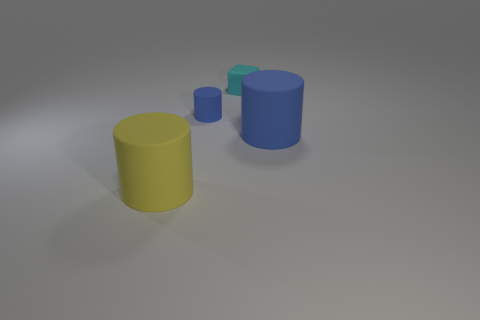How many blue cylinders must be subtracted to get 1 blue cylinders? 1 Subtract all brown spheres. How many blue cylinders are left? 2 Subtract all large cylinders. How many cylinders are left? 1 Subtract all gray cylinders. Subtract all yellow spheres. How many cylinders are left? 3 Add 4 big blue cylinders. How many objects exist? 8 Add 2 big purple matte cylinders. How many big purple matte cylinders exist? 2 Subtract 2 blue cylinders. How many objects are left? 2 Subtract all cylinders. How many objects are left? 1 Subtract all large yellow objects. Subtract all tiny rubber objects. How many objects are left? 1 Add 4 cyan rubber objects. How many cyan rubber objects are left? 5 